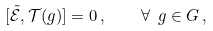<formula> <loc_0><loc_0><loc_500><loc_500>[ \mathcal { \tilde { E } } , \mathcal { T } ( g ) ] = 0 \, , \quad \forall \ g \in G \, ,</formula> 